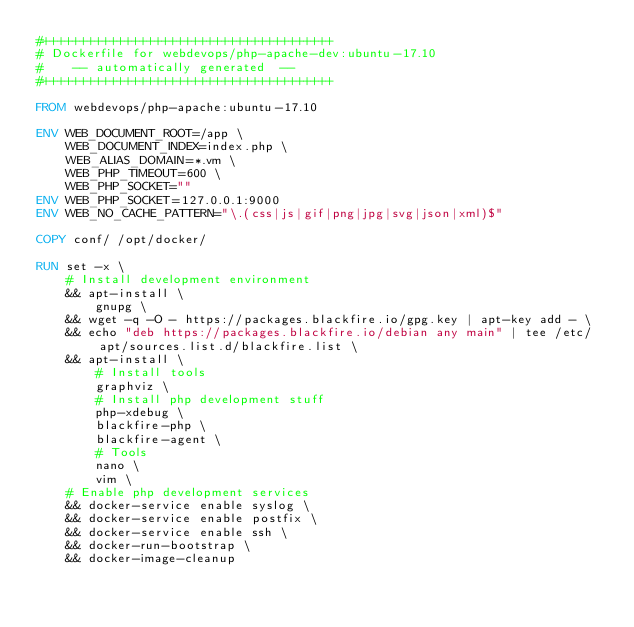Convert code to text. <code><loc_0><loc_0><loc_500><loc_500><_Dockerfile_>#+++++++++++++++++++++++++++++++++++++++
# Dockerfile for webdevops/php-apache-dev:ubuntu-17.10
#    -- automatically generated  --
#+++++++++++++++++++++++++++++++++++++++

FROM webdevops/php-apache:ubuntu-17.10

ENV WEB_DOCUMENT_ROOT=/app \
    WEB_DOCUMENT_INDEX=index.php \
    WEB_ALIAS_DOMAIN=*.vm \
    WEB_PHP_TIMEOUT=600 \
    WEB_PHP_SOCKET=""
ENV WEB_PHP_SOCKET=127.0.0.1:9000
ENV WEB_NO_CACHE_PATTERN="\.(css|js|gif|png|jpg|svg|json|xml)$"

COPY conf/ /opt/docker/

RUN set -x \
    # Install development environment
    && apt-install \
        gnupg \
    && wget -q -O - https://packages.blackfire.io/gpg.key | apt-key add - \
    && echo "deb https://packages.blackfire.io/debian any main" | tee /etc/apt/sources.list.d/blackfire.list \
    && apt-install \
        # Install tools
        graphviz \
        # Install php development stuff
        php-xdebug \
        blackfire-php \
        blackfire-agent \
        # Tools
        nano \
        vim \
    # Enable php development services
    && docker-service enable syslog \
    && docker-service enable postfix \
    && docker-service enable ssh \
    && docker-run-bootstrap \
    && docker-image-cleanup
</code> 